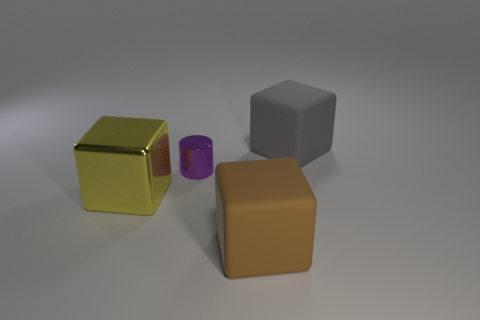Add 3 small metallic balls. How many objects exist? 7 Subtract all blocks. How many objects are left? 1 Subtract 0 green spheres. How many objects are left? 4 Subtract all brown rubber things. Subtract all big cyan shiny cubes. How many objects are left? 3 Add 2 yellow metallic cubes. How many yellow metallic cubes are left? 3 Add 1 large yellow metallic things. How many large yellow metallic things exist? 2 